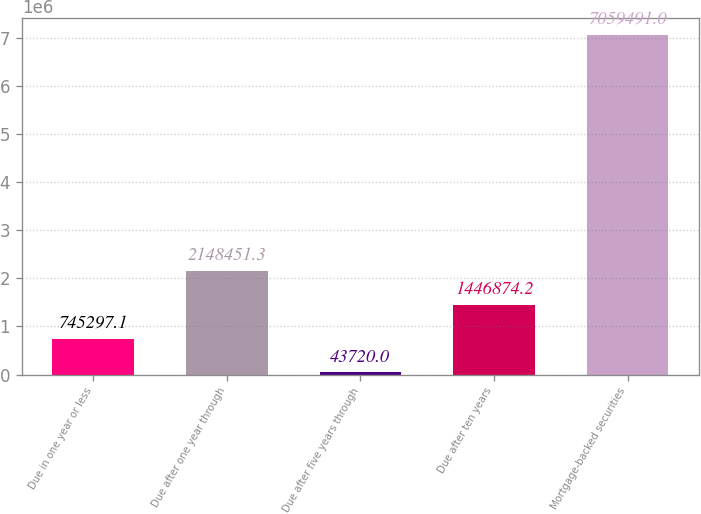Convert chart to OTSL. <chart><loc_0><loc_0><loc_500><loc_500><bar_chart><fcel>Due in one year or less<fcel>Due after one year through<fcel>Due after five years through<fcel>Due after ten years<fcel>Mortgage-backed securities<nl><fcel>745297<fcel>2.14845e+06<fcel>43720<fcel>1.44687e+06<fcel>7.05949e+06<nl></chart> 